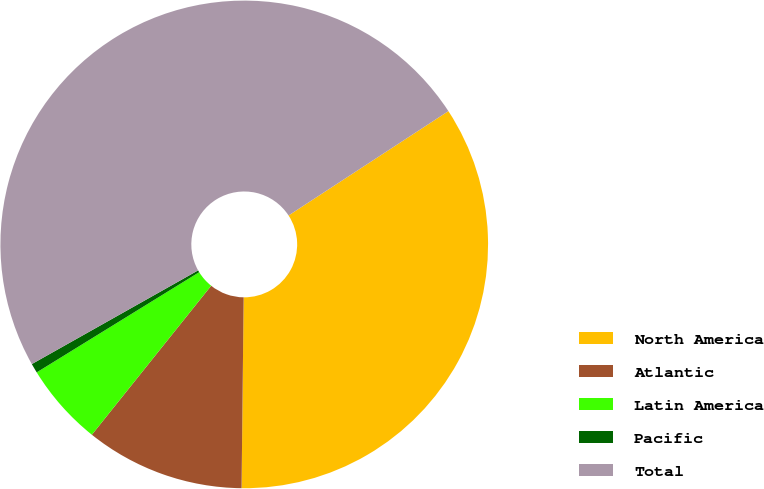Convert chart to OTSL. <chart><loc_0><loc_0><loc_500><loc_500><pie_chart><fcel>North America<fcel>Atlantic<fcel>Latin America<fcel>Pacific<fcel>Total<nl><fcel>34.38%<fcel>10.57%<fcel>5.46%<fcel>0.63%<fcel>48.96%<nl></chart> 